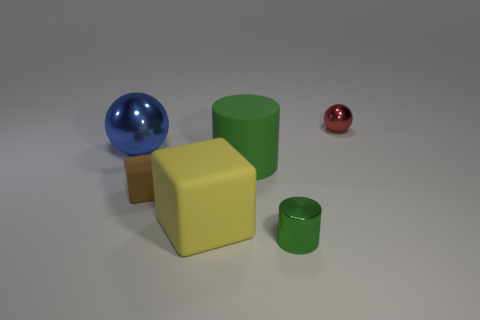The cylinder that is the same size as the brown matte cube is what color?
Make the answer very short. Green. There is a matte cube left of the big yellow object; does it have the same size as the sphere that is on the left side of the small matte block?
Offer a terse response. No. What size is the ball left of the metallic sphere to the right of the metallic sphere that is left of the tiny brown matte cube?
Ensure brevity in your answer.  Large. There is a metal object that is in front of the block in front of the brown matte object; what shape is it?
Your answer should be very brief. Cylinder. Does the large rubber object in front of the small matte object have the same color as the small rubber cube?
Offer a very short reply. No. There is a rubber object that is both behind the big yellow block and to the right of the tiny brown matte block; what is its color?
Provide a succinct answer. Green. Are there any other large blue spheres made of the same material as the large blue sphere?
Give a very brief answer. No. The blue shiny sphere is what size?
Your response must be concise. Large. What is the size of the green cylinder that is behind the metallic object in front of the large green matte thing?
Make the answer very short. Large. What material is the other thing that is the same shape as the yellow thing?
Keep it short and to the point. Rubber. 